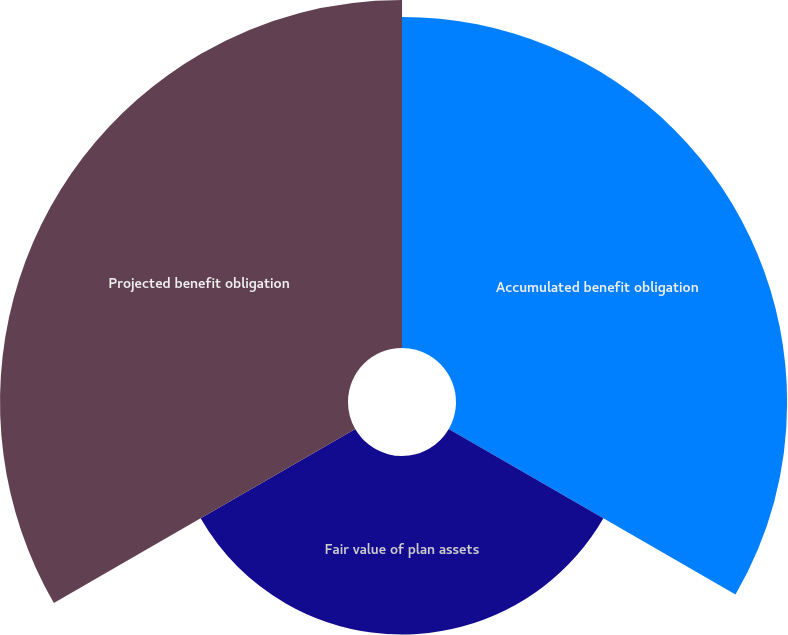Convert chart. <chart><loc_0><loc_0><loc_500><loc_500><pie_chart><fcel>Accumulated benefit obligation<fcel>Fair value of plan assets<fcel>Projected benefit obligation<nl><fcel>38.61%<fcel>20.82%<fcel>40.58%<nl></chart> 